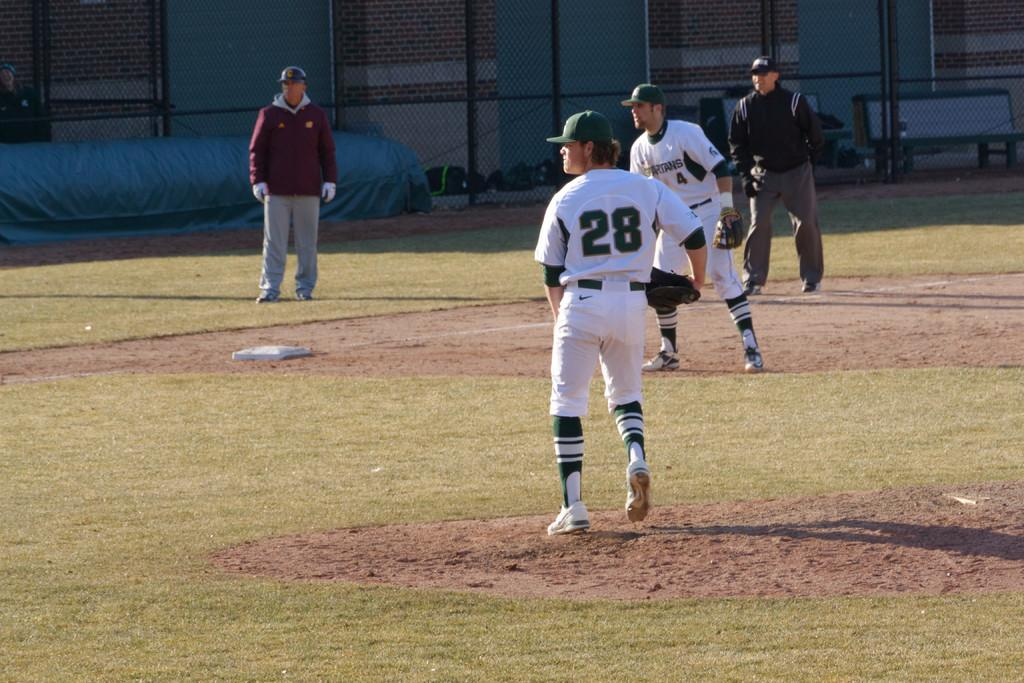Provide a one-sentence caption for the provided image. Player number 28 is the pitcher in a baseball game taking place on a sunny day. 